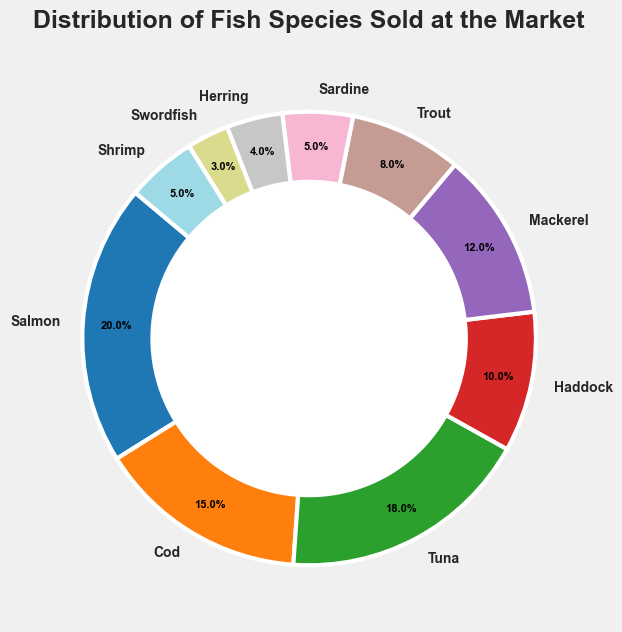What's the fish species with the smallest market share? The smallest segment in the ring chart represents the fish species with the lowest percentage. Here it’s shown as 3%, which corresponds to Swordfish.
Answer: Swordfish Which fish species contributes the most to the total sales? The largest segment in the ring chart represents the fish species with the highest percentage. Here it’s 20%, which corresponds to Salmon.
Answer: Salmon What is the combined market share of Haddock and Shrimp? From the ring chart, Haddock has a 10% share and Shrimp has a 5% share. Adding these two percentages together gives 10% + 5% = 15%.
Answer: 15% Is the market share of Tuna greater than Mackerel? The chart shows Tuna at 18% and Mackerel at 12%. Comparing these two values, 18% is greater than 12%.
Answer: Yes What is the difference in market share between Cod and Trout? From the chart, Cod stands at 15% and Trout at 8%. The difference is calculated as 15% - 8% = 7%.
Answer: 7% Which species have a market share less than 10%? The segments with under 10% market share are Haddock (10%), Trout (8%), Sardine (5%), Herring (4%), and Swordfish (3%).
Answer: Haddock, Trout, Sardine, Herring, Swordfish Combining the shares of Mackerel, Shrimp, and Herring, what is the total percentage? Mackerel has 12%, Shrimp has 5%, and Herring has 4%. Adding these together, 12% + 5% + 4% = 21%.
Answer: 21% Which species have a market share that is exactly half of the leading species? The leading species, Salmon, has a 20% market share. Half of 20% is 10%. Checking the chart, Haddock has a 10% share which matches this condition.
Answer: Haddock Are there any species that individually contribute the same market share? On inspecting the chart, both Sardine and Shrimp each contribute 5% to the total sales.
Answer: Yes What is the average market share of Salmon, Cod, and Tuna combined? Summing their shares: Salmon (20%), Cod (15%), and Tuna (18%) gives 20% + 15% + 18% = 53%. There are three species, so the average is 53% / 3 ≈ 17.67%.
Answer: 17.67% 